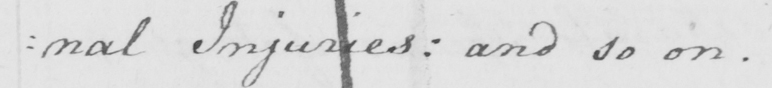Can you read and transcribe this handwriting? : nal Injuries :  and so on . 